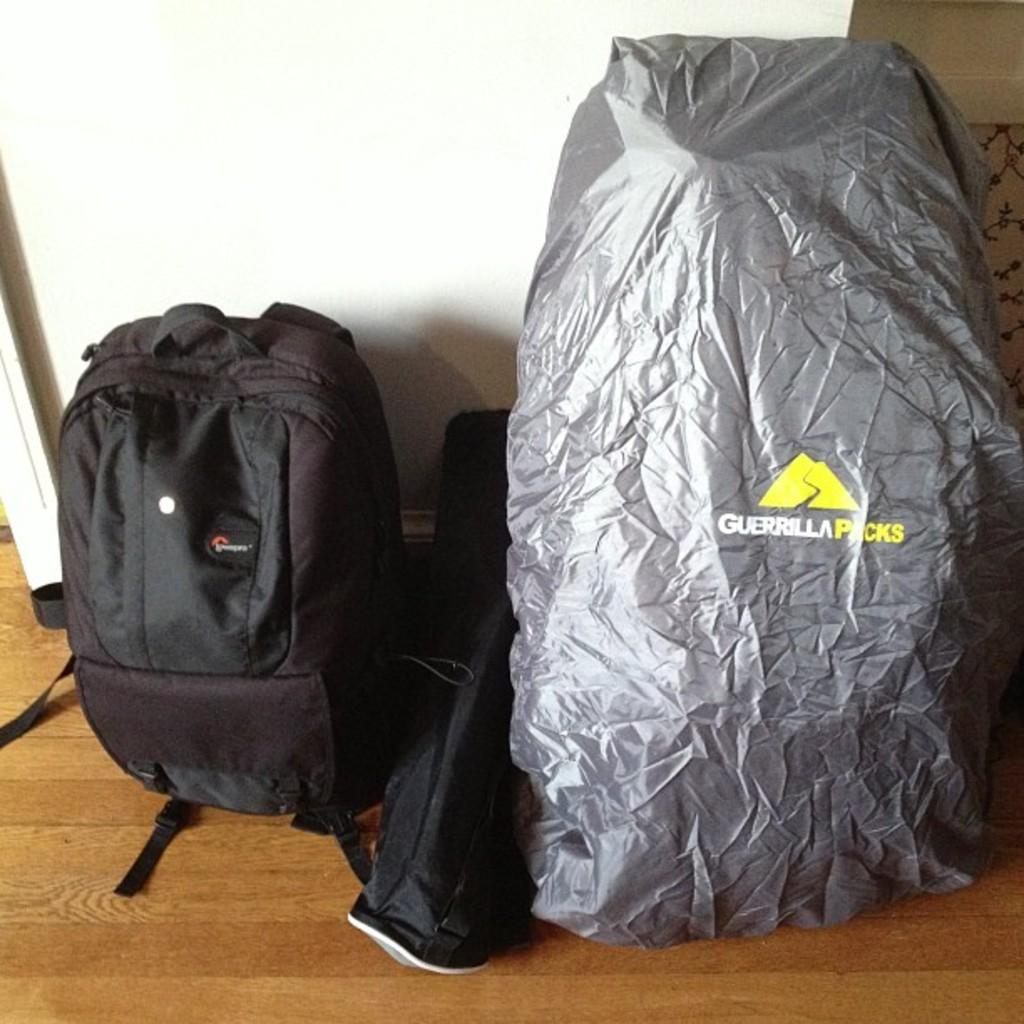What is placed on the floor in the image? There is a black bag and a gray color cover on the floor. Can you describe the wall in the background of the image? There is a wall in the background of the image, but no specific details about its color or features are provided. What is the color of the bag on the floor? The bag on the floor is black. What type of leather is used to make the ants in the image? There are no ants present in the image, and therefore no leather or any other material is used to make them. 